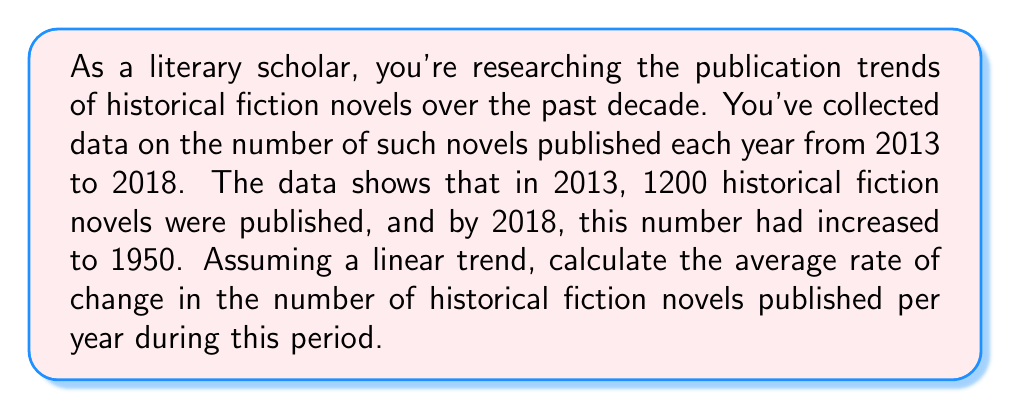Provide a solution to this math problem. To solve this problem, we'll use the concept of average rate of change. The formula for the average rate of change is:

$$\text{Average rate of change} = \frac{\text{Change in y}}{\text{Change in x}}$$

In this case:
- y represents the number of historical fiction novels published
- x represents the year

We're given:
- Initial year (2013): $x_1 = 2013$
- Final year (2018): $x_2 = 2018$
- Initial number of novels (2013): $y_1 = 1200$
- Final number of novels (2018): $y_2 = 1950$

Let's calculate:

1. Change in x (time period):
   $\Delta x = x_2 - x_1 = 2018 - 2013 = 5$ years

2. Change in y (number of novels):
   $\Delta y = y_2 - y_1 = 1950 - 1200 = 750$ novels

3. Apply the average rate of change formula:

   $$\text{Average rate of change} = \frac{\Delta y}{\Delta x} = \frac{750}{5} = 150$$

This means that, on average, the number of historical fiction novels published increased by 150 per year from 2013 to 2018.
Answer: The average rate of change in the number of historical fiction novels published per year from 2013 to 2018 is 150 novels per year. 